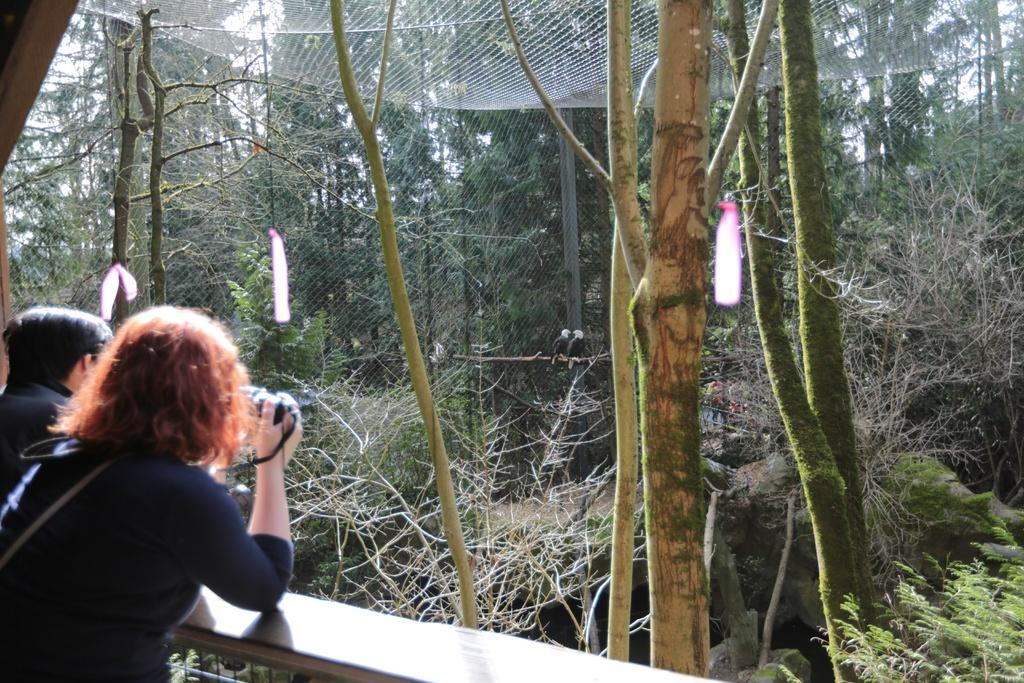How many people are in the image? There are people in the image, but the exact number is not specified. What is one of the people doing in the image? One of the people is holding an object. What can be seen in the background of the image? There are trees and a net visible in the background. What material is present at the bottom of the image? There is wood at the bottom of the image. What type of animal is being ridden by the maid in the image? There is no maid or animal present in the image. How does the carriage move in the image? There is no carriage present in the image. 